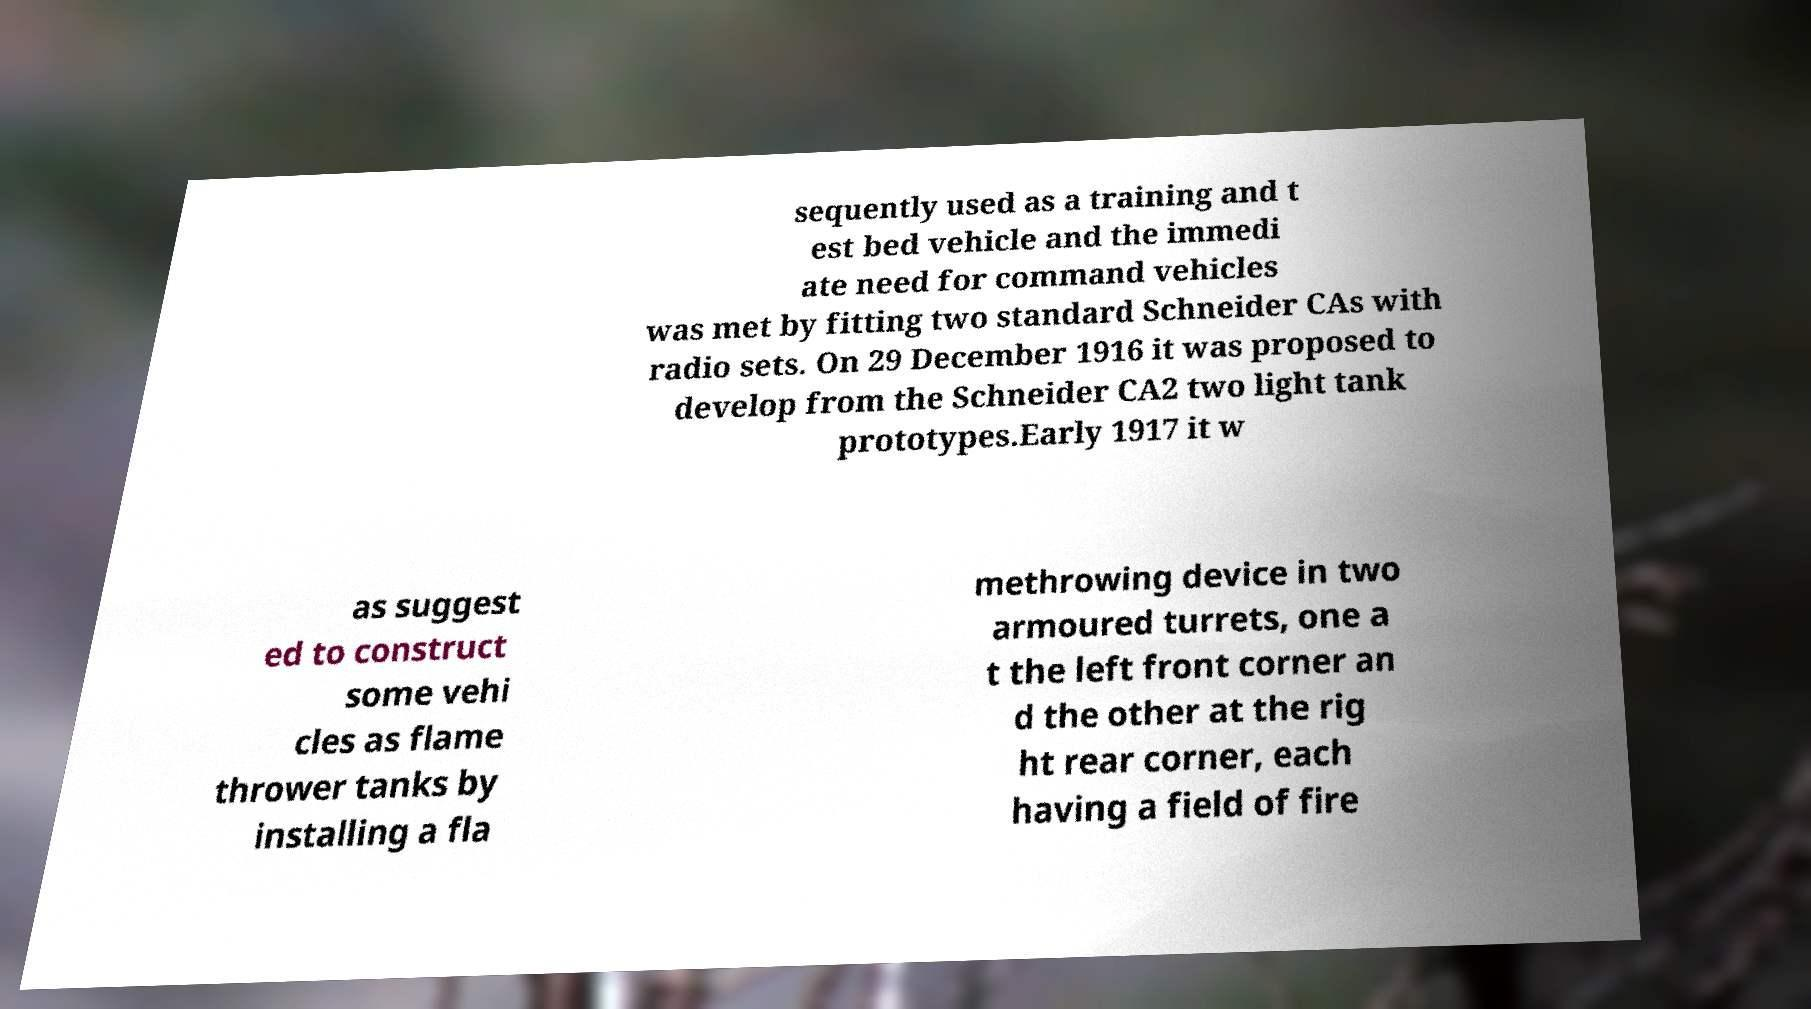Can you accurately transcribe the text from the provided image for me? sequently used as a training and t est bed vehicle and the immedi ate need for command vehicles was met by fitting two standard Schneider CAs with radio sets. On 29 December 1916 it was proposed to develop from the Schneider CA2 two light tank prototypes.Early 1917 it w as suggest ed to construct some vehi cles as flame thrower tanks by installing a fla methrowing device in two armoured turrets, one a t the left front corner an d the other at the rig ht rear corner, each having a field of fire 